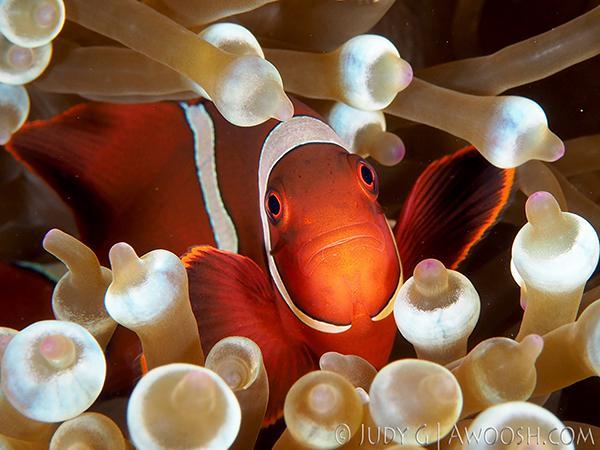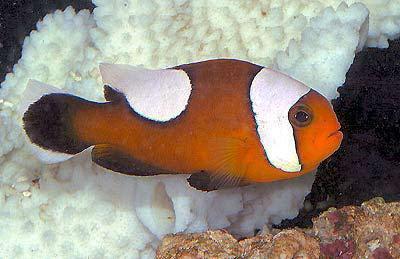The first image is the image on the left, the second image is the image on the right. Considering the images on both sides, is "One image shows a clown fish facing fully forward and surrounded by nipple-like structures." valid? Answer yes or no. Yes. 